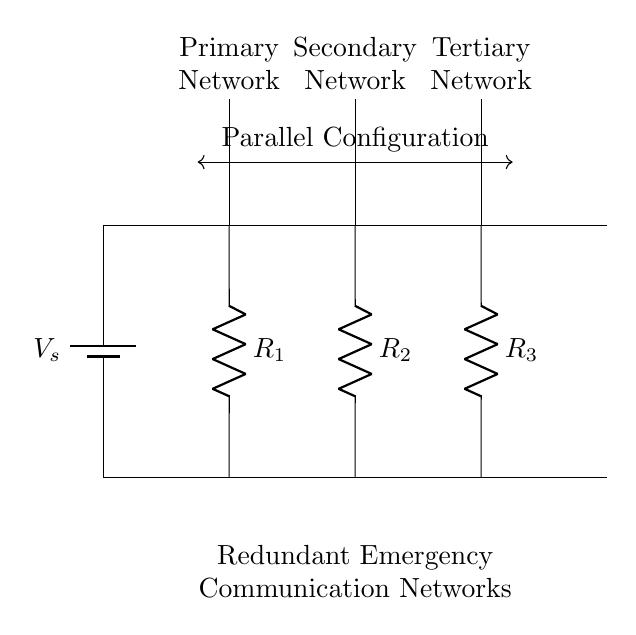What is the voltage source in this circuit? The circuit contains a voltage source labeled as V_s. This is indicated at the top left of the diagram, where the battery symbol is drawn.
Answer: V_s How many antenna components are present in the circuit? There are three antenna components, as seen at the top of the circuit where each network is labeled with an antenna symbol. This is confirmed by counting the distinct antenna symbols placed at intervals of the circuit.
Answer: 3 What are the names of the three networks in this circuit? The networks are named Primary Network, Secondary Network, and Tertiary Network. These names are indicated by labels next to each antenna in the circuit diagram.
Answer: Primary, Secondary, Tertiary What is the relationship of the resistors in this circuit? The resistors R_1, R_2, and R_3 are connected in parallel, as they all connect to the same voltage level (the voltage source) and have separate paths to the ground. This is determined by observing that each resistor is connected between the same two points: the voltage source and the ground.
Answer: Parallel Which resistor has the highest potential difference across it? In a parallel circuit, all resistors share the same potential difference, which is the same as the voltage of the source V_s. This is determined by the properties of parallel connections, where voltage remains constant across all branches.
Answer: V_s 